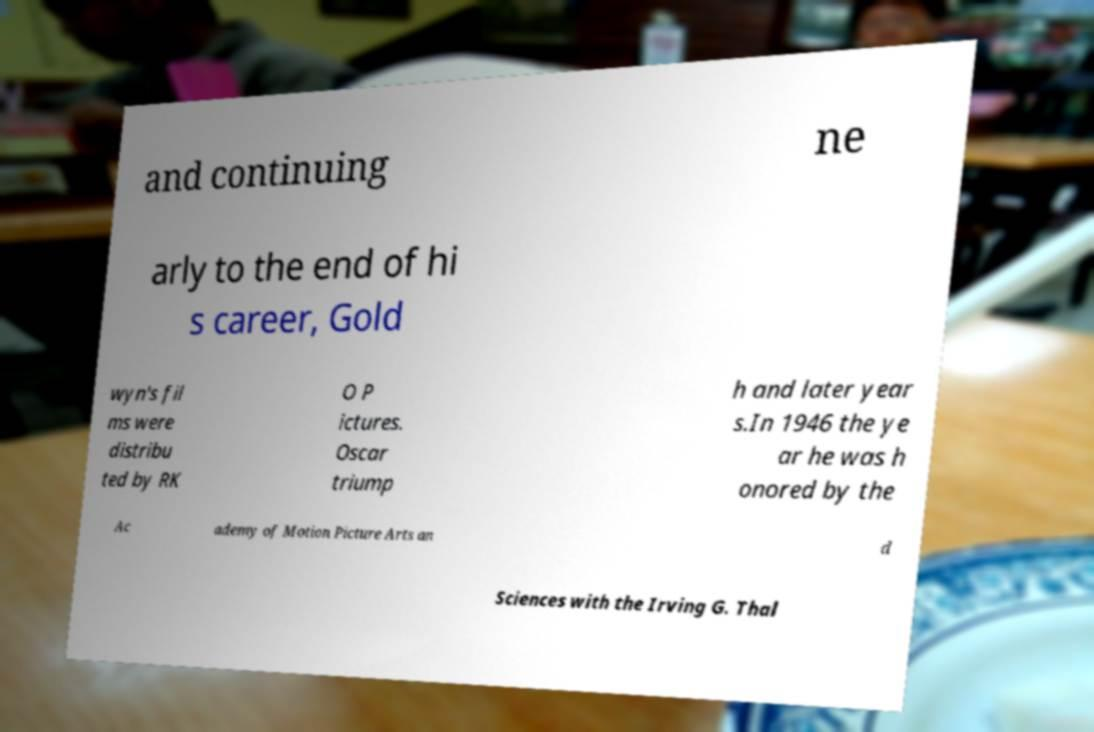Please identify and transcribe the text found in this image. and continuing ne arly to the end of hi s career, Gold wyn's fil ms were distribu ted by RK O P ictures. Oscar triump h and later year s.In 1946 the ye ar he was h onored by the Ac ademy of Motion Picture Arts an d Sciences with the Irving G. Thal 